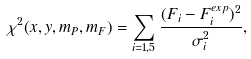Convert formula to latex. <formula><loc_0><loc_0><loc_500><loc_500>\chi ^ { 2 } ( x , y , m _ { P } , m _ { F } ) = \sum _ { i = 1 , 5 } \frac { ( F _ { i } - F _ { i } ^ { e x p } ) ^ { 2 } } { \sigma _ { i } ^ { 2 } } ,</formula> 